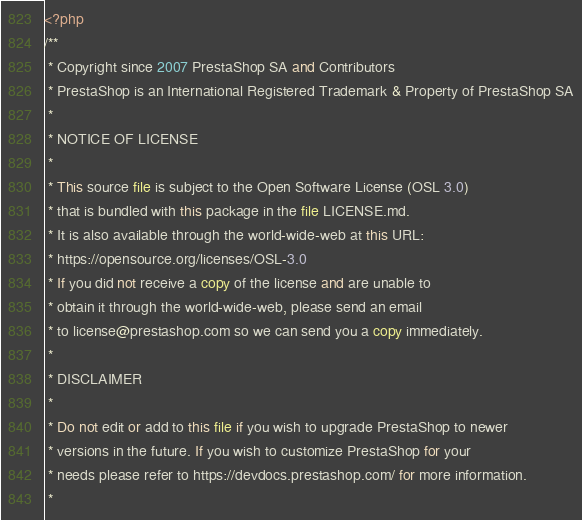<code> <loc_0><loc_0><loc_500><loc_500><_PHP_><?php
/**
 * Copyright since 2007 PrestaShop SA and Contributors
 * PrestaShop is an International Registered Trademark & Property of PrestaShop SA
 *
 * NOTICE OF LICENSE
 *
 * This source file is subject to the Open Software License (OSL 3.0)
 * that is bundled with this package in the file LICENSE.md.
 * It is also available through the world-wide-web at this URL:
 * https://opensource.org/licenses/OSL-3.0
 * If you did not receive a copy of the license and are unable to
 * obtain it through the world-wide-web, please send an email
 * to license@prestashop.com so we can send you a copy immediately.
 *
 * DISCLAIMER
 *
 * Do not edit or add to this file if you wish to upgrade PrestaShop to newer
 * versions in the future. If you wish to customize PrestaShop for your
 * needs please refer to https://devdocs.prestashop.com/ for more information.
 *</code> 